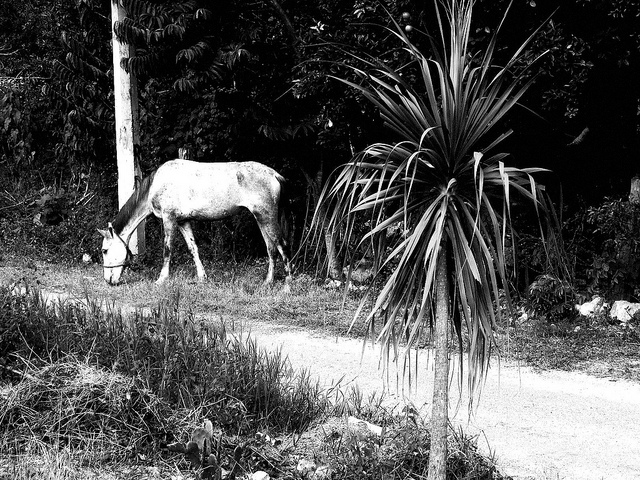How many people are wearing sunglasses? 0 